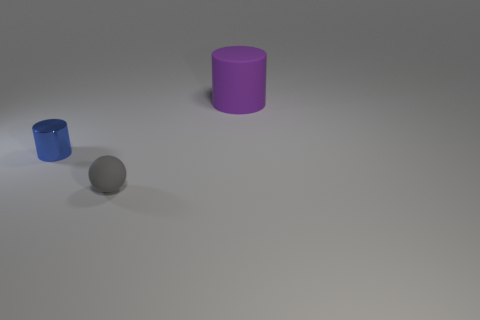There is a object that is left of the matte object that is in front of the cylinder in front of the purple matte thing; what is its shape?
Offer a very short reply. Cylinder. What number of other things are the same shape as the tiny gray thing?
Provide a short and direct response. 0. What number of tiny blue metallic objects are there?
Your answer should be compact. 1. How many things are either tiny blue metallic cylinders or purple rubber objects?
Your answer should be very brief. 2. Are there any tiny objects in front of the blue shiny object?
Ensure brevity in your answer.  Yes. Are there more things that are in front of the big purple object than big cylinders that are in front of the small shiny cylinder?
Make the answer very short. Yes. There is a purple object that is the same shape as the blue metallic thing; what is its size?
Offer a very short reply. Large. How many cylinders are large purple objects or gray things?
Ensure brevity in your answer.  1. Are there fewer matte things that are to the right of the rubber sphere than objects to the right of the small metallic cylinder?
Your response must be concise. Yes. What number of things are cylinders that are right of the gray rubber thing or tiny cylinders?
Offer a terse response. 2. 